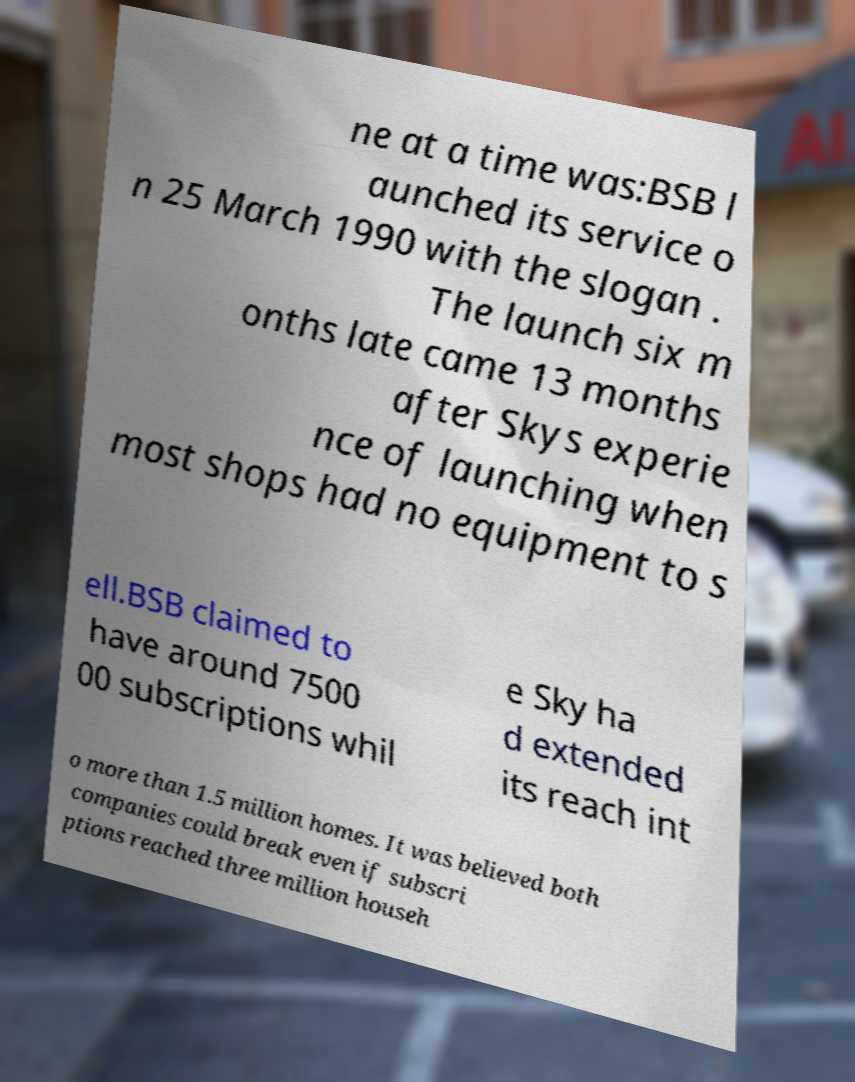Could you extract and type out the text from this image? ne at a time was:BSB l aunched its service o n 25 March 1990 with the slogan . The launch six m onths late came 13 months after Skys experie nce of launching when most shops had no equipment to s ell.BSB claimed to have around 7500 00 subscriptions whil e Sky ha d extended its reach int o more than 1.5 million homes. It was believed both companies could break even if subscri ptions reached three million househ 